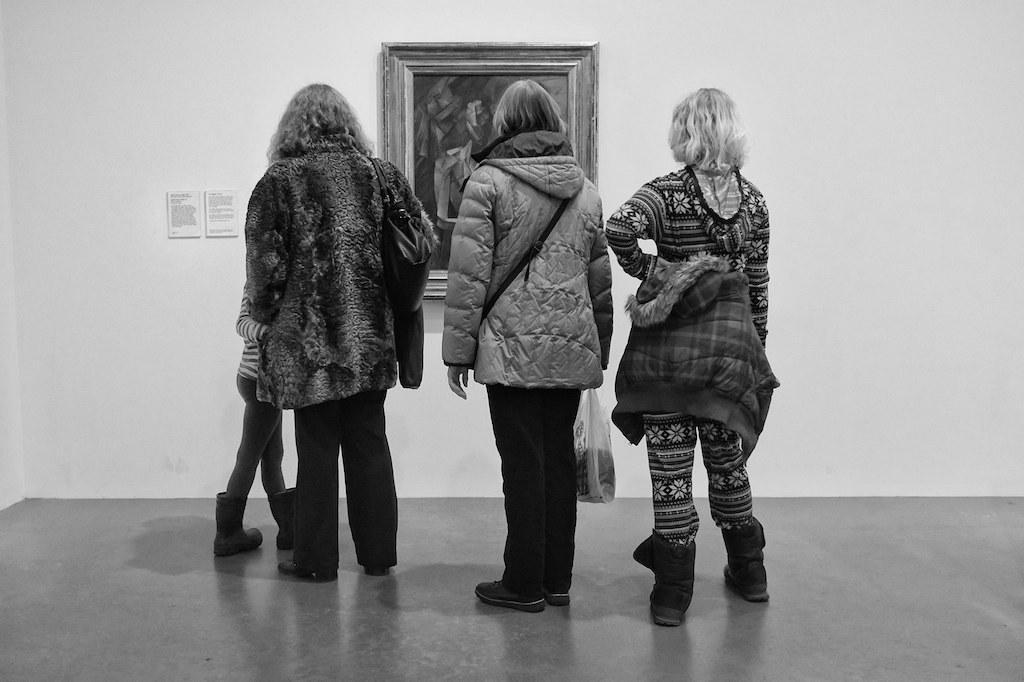Can you describe this image briefly? This is a black and white image. In the center we can see the group of person standing on the ground. In the background there is a wall and a picture frame hanging on the wall and we can see the two papers attached to the wall on which the text is printed. 